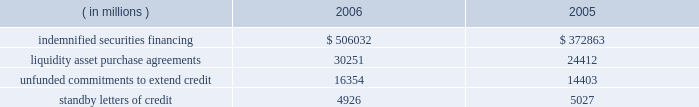State street bank issuances : state street bank currently has authority to issue up to an aggregate of $ 1 billion of subordinated fixed-rate , floating-rate or zero-coupon bank notes with a maturity of five to fifteen years .
With respect to the 5.25% ( 5.25 % ) subordinated bank notes due 2018 , state street bank is required to make semi-annual interest payments on the outstanding principal balance of the notes on april 15 and october 15 of each year , and the notes qualify as tier 2 capital under regulatory capital guidelines .
With respect to the 5.30% ( 5.30 % ) subordinated notes due 2016 and the floating-rate subordinated notes due 2015 , state street bank is required to make semi-annual interest payments on the outstanding principal balance of the 5.30% ( 5.30 % ) notes on january 15 and july 15 of each year beginning in july 2006 , and quarterly interest payments on the outstanding principal balance of the floating-rate notes on march 8 , june 8 , september 8 and december 8 of each year beginning in march 2006 .
The notes qualify as tier 2 capital under regulatory capital guidelines .
Note 10 .
Commitments and contingencies off-balance sheet commitments and contingencies : credit-related financial instruments include indemnified securities financing , unfunded commitments to extend credit or purchase assets and standby letters of credit .
The total potential loss on unfunded commitments , standby and commercial letters of credit and securities finance indemnifications is equal to the total contractual amount , which does not consider the value of any collateral .
The following is a summary of the contractual amount of credit-related , off-balance sheet financial instruments at december 31 .
Amounts reported do not reflect participations to unrelated third parties. .
On behalf of our customers , we lend their securities to creditworthy brokers and other institutions .
In certain circumstances , we may indemnify our customers for the fair market value of those securities against a failure of the borrower to return such securities .
Collateral funds received in connection with our securities finance services are held by us as agent and are not recorded in our consolidated statement of condition .
We require the borrowers to provide collateral in an amount equal to or in excess of 100% ( 100 % ) of the fair market value of the securities borrowed .
The borrowed securities are revalued daily to determine if additional collateral is necessary .
We held , as agent , cash and u.s .
Government securities totaling $ 527.37 billion and $ 387.22 billion as collateral for indemnified securities on loan at december 31 , 2006 and 2005 , respectively .
Approximately 81% ( 81 % ) of the unfunded commitments to extend credit and liquidity asset purchase agreements expire within one year from the date of issue .
Since many of the commitments are expected to expire or renew without being drawn upon , the total commitment amounts do not necessarily represent future cash requirements .
In the normal course of business , we provide liquidity and credit enhancements to asset-backed commercial paper programs , or 201cconduits . 201d these conduits are more fully described in note 11 .
The commercial paper issuances and commitments of the conduits to provide funding are supported by liquidity asset purchase agreements and backup liquidity lines of credit , the majority of which are provided by us .
In addition , we provide direct credit support to the conduits in the form of standby letters of credit .
Our commitments under liquidity asset purchase agreements and backup lines of credit totaled $ 23.99 billion at december 31 , 2006 , and are included in the preceding table .
Our commitments under seq 83 copyarea : 38 .
X 54 .
Trimsize : 8.25 x 10.75 typeset state street corporation serverprocess c:\\fc\\delivery_1024177\\2771-1-dm_p.pdf chksum : 0 cycle 1merrill corporation 07-2771-1 thu mar 01 17:10:46 2007 ( v 2.247w--stp1pae18 ) .
What is the total of credit-related financial instruments in 2006? ( $ )? 
Computations: (((506032 + 30251) + 16354) + 4926)
Answer: 557563.0. 